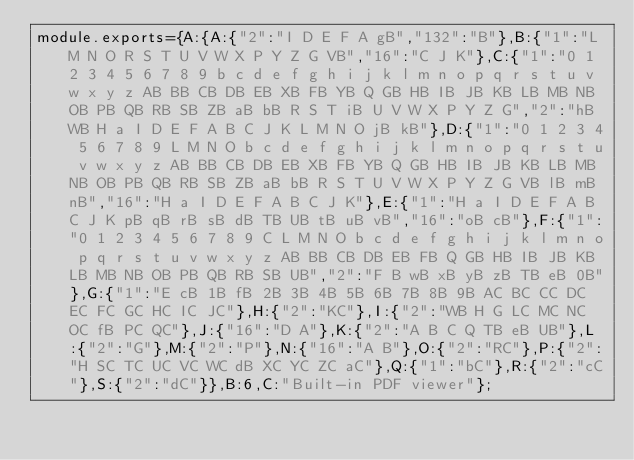<code> <loc_0><loc_0><loc_500><loc_500><_JavaScript_>module.exports={A:{A:{"2":"I D E F A gB","132":"B"},B:{"1":"L M N O R S T U V W X P Y Z G VB","16":"C J K"},C:{"1":"0 1 2 3 4 5 6 7 8 9 b c d e f g h i j k l m n o p q r s t u v w x y z AB BB CB DB EB XB FB YB Q GB HB IB JB KB LB MB NB OB PB QB RB SB ZB aB bB R S T iB U V W X P Y Z G","2":"hB WB H a I D E F A B C J K L M N O jB kB"},D:{"1":"0 1 2 3 4 5 6 7 8 9 L M N O b c d e f g h i j k l m n o p q r s t u v w x y z AB BB CB DB EB XB FB YB Q GB HB IB JB KB LB MB NB OB PB QB RB SB ZB aB bB R S T U V W X P Y Z G VB lB mB nB","16":"H a I D E F A B C J K"},E:{"1":"H a I D E F A B C J K pB qB rB sB dB TB UB tB uB vB","16":"oB cB"},F:{"1":"0 1 2 3 4 5 6 7 8 9 C L M N O b c d e f g h i j k l m n o p q r s t u v w x y z AB BB CB DB EB FB Q GB HB IB JB KB LB MB NB OB PB QB RB SB UB","2":"F B wB xB yB zB TB eB 0B"},G:{"1":"E cB 1B fB 2B 3B 4B 5B 6B 7B 8B 9B AC BC CC DC EC FC GC HC IC JC"},H:{"2":"KC"},I:{"2":"WB H G LC MC NC OC fB PC QC"},J:{"16":"D A"},K:{"2":"A B C Q TB eB UB"},L:{"2":"G"},M:{"2":"P"},N:{"16":"A B"},O:{"2":"RC"},P:{"2":"H SC TC UC VC WC dB XC YC ZC aC"},Q:{"1":"bC"},R:{"2":"cC"},S:{"2":"dC"}},B:6,C:"Built-in PDF viewer"};
</code> 